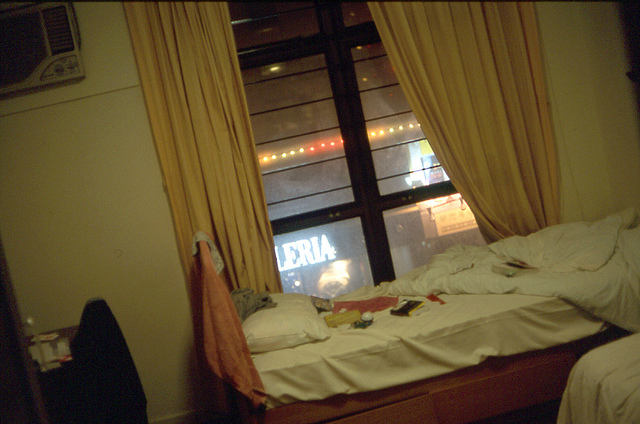<image>What kind of window treatments are featured here? I am not sure what kind of window treatments are featured here. They can be curtains, drapes, or panel curtains. What pattern is on the quilt? There is no pattern on the quilt. However, it can be solid or plain. What pattern is on the quilt? The pattern on the quilt is solid or plain. What kind of window treatments are featured here? I don't know what kind of window treatments are featured here. It can be seen as 'yellow curtains', 'curtains', 'none', 'frosting', 'curtain', 'drapes', or 'panel curtains'. 